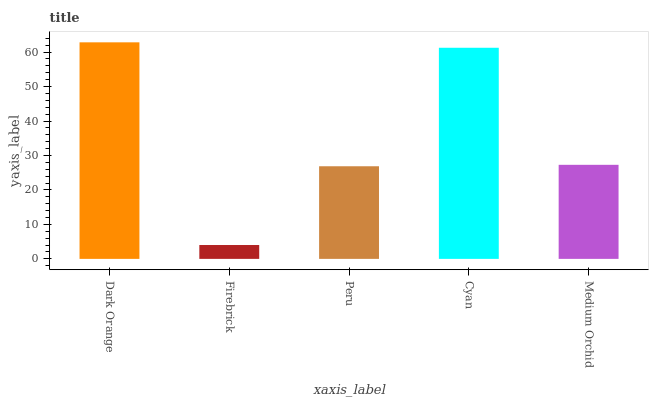Is Firebrick the minimum?
Answer yes or no. Yes. Is Dark Orange the maximum?
Answer yes or no. Yes. Is Peru the minimum?
Answer yes or no. No. Is Peru the maximum?
Answer yes or no. No. Is Peru greater than Firebrick?
Answer yes or no. Yes. Is Firebrick less than Peru?
Answer yes or no. Yes. Is Firebrick greater than Peru?
Answer yes or no. No. Is Peru less than Firebrick?
Answer yes or no. No. Is Medium Orchid the high median?
Answer yes or no. Yes. Is Medium Orchid the low median?
Answer yes or no. Yes. Is Firebrick the high median?
Answer yes or no. No. Is Dark Orange the low median?
Answer yes or no. No. 